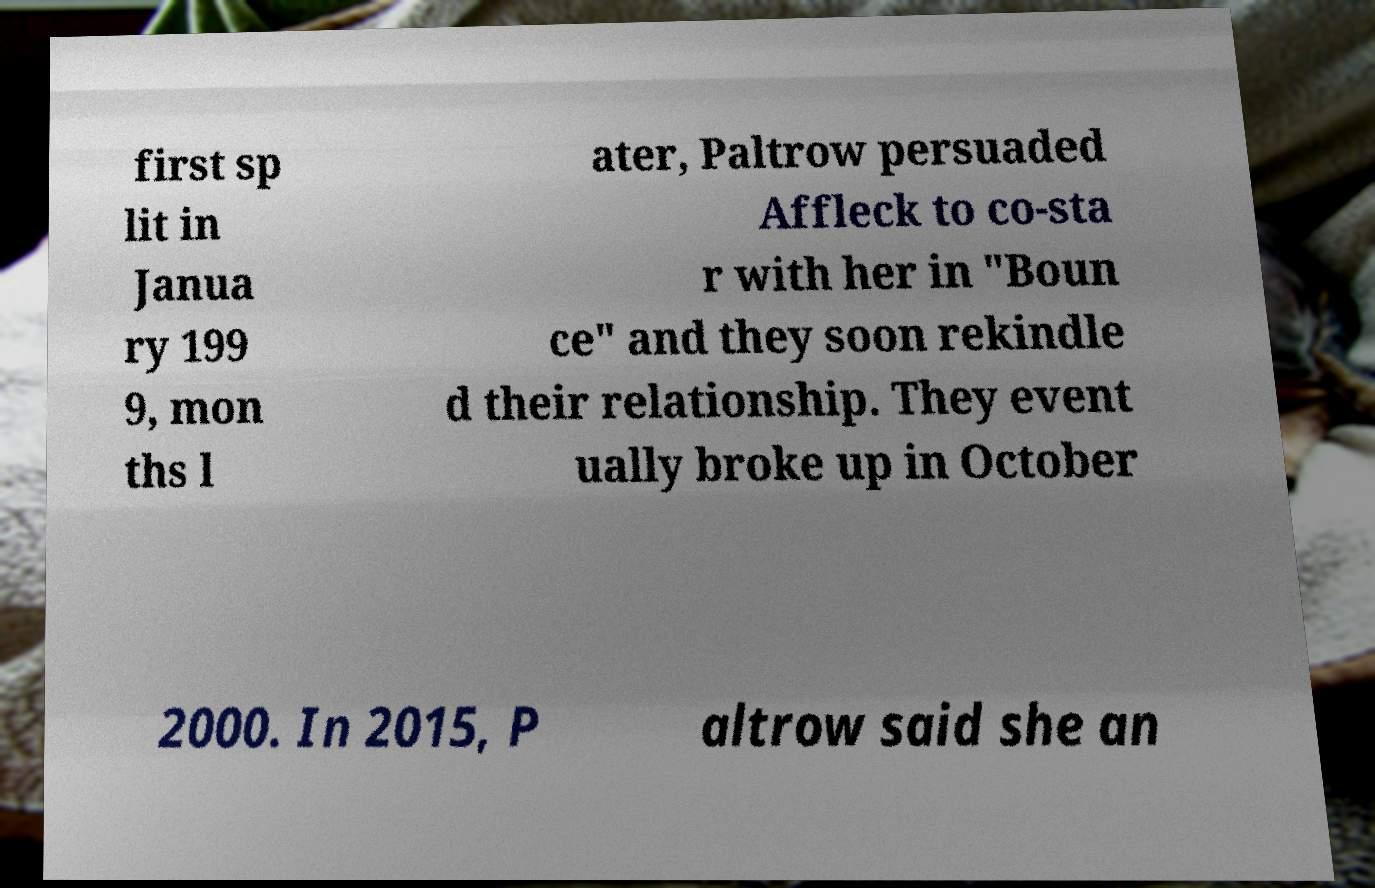Please read and relay the text visible in this image. What does it say? first sp lit in Janua ry 199 9, mon ths l ater, Paltrow persuaded Affleck to co-sta r with her in "Boun ce" and they soon rekindle d their relationship. They event ually broke up in October 2000. In 2015, P altrow said she an 